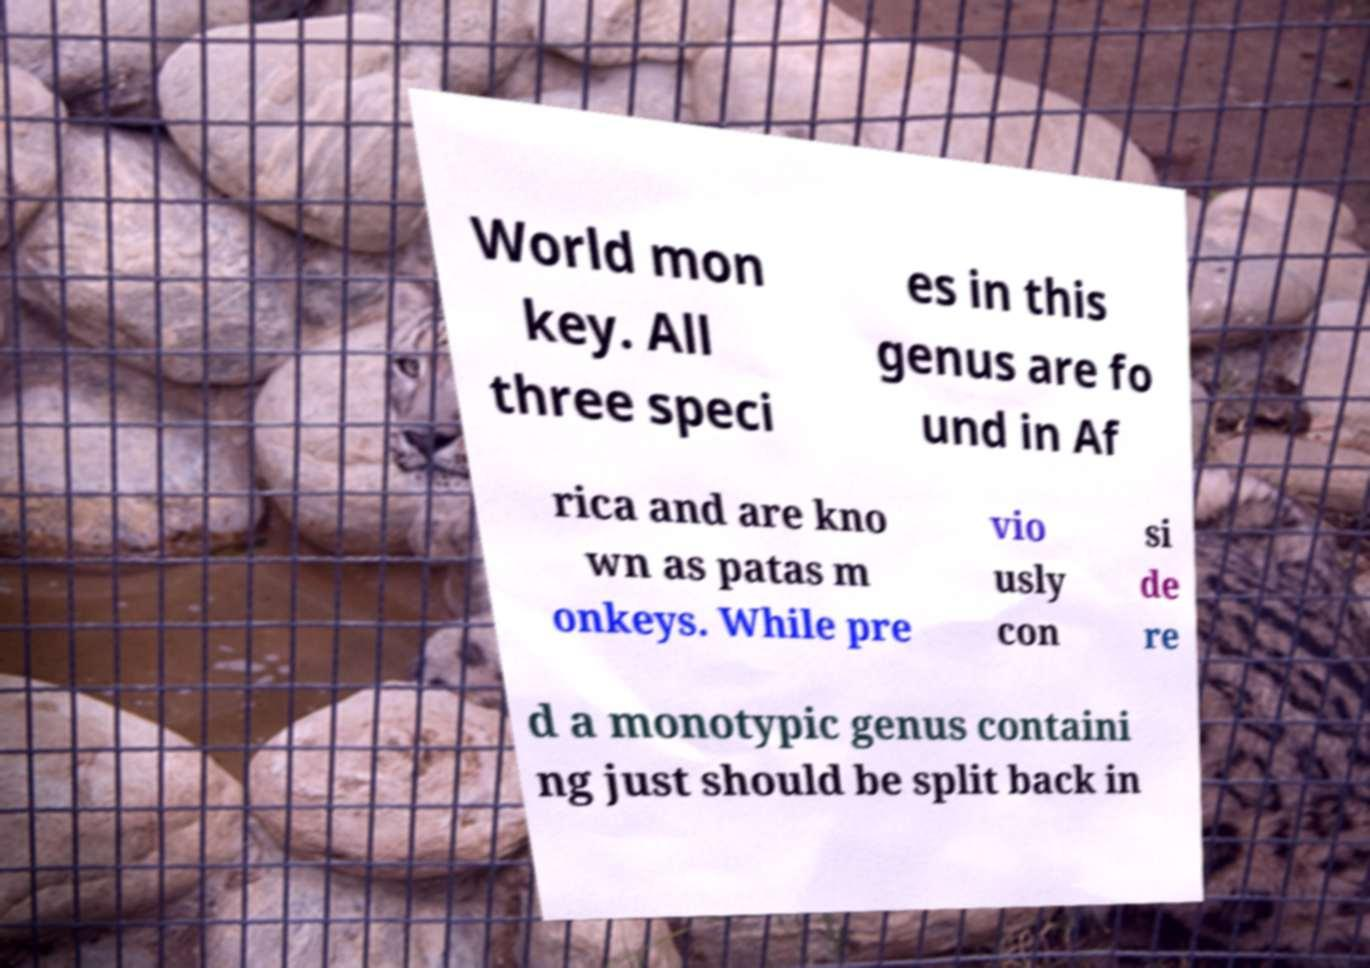Can you read and provide the text displayed in the image?This photo seems to have some interesting text. Can you extract and type it out for me? World mon key. All three speci es in this genus are fo und in Af rica and are kno wn as patas m onkeys. While pre vio usly con si de re d a monotypic genus containi ng just should be split back in 